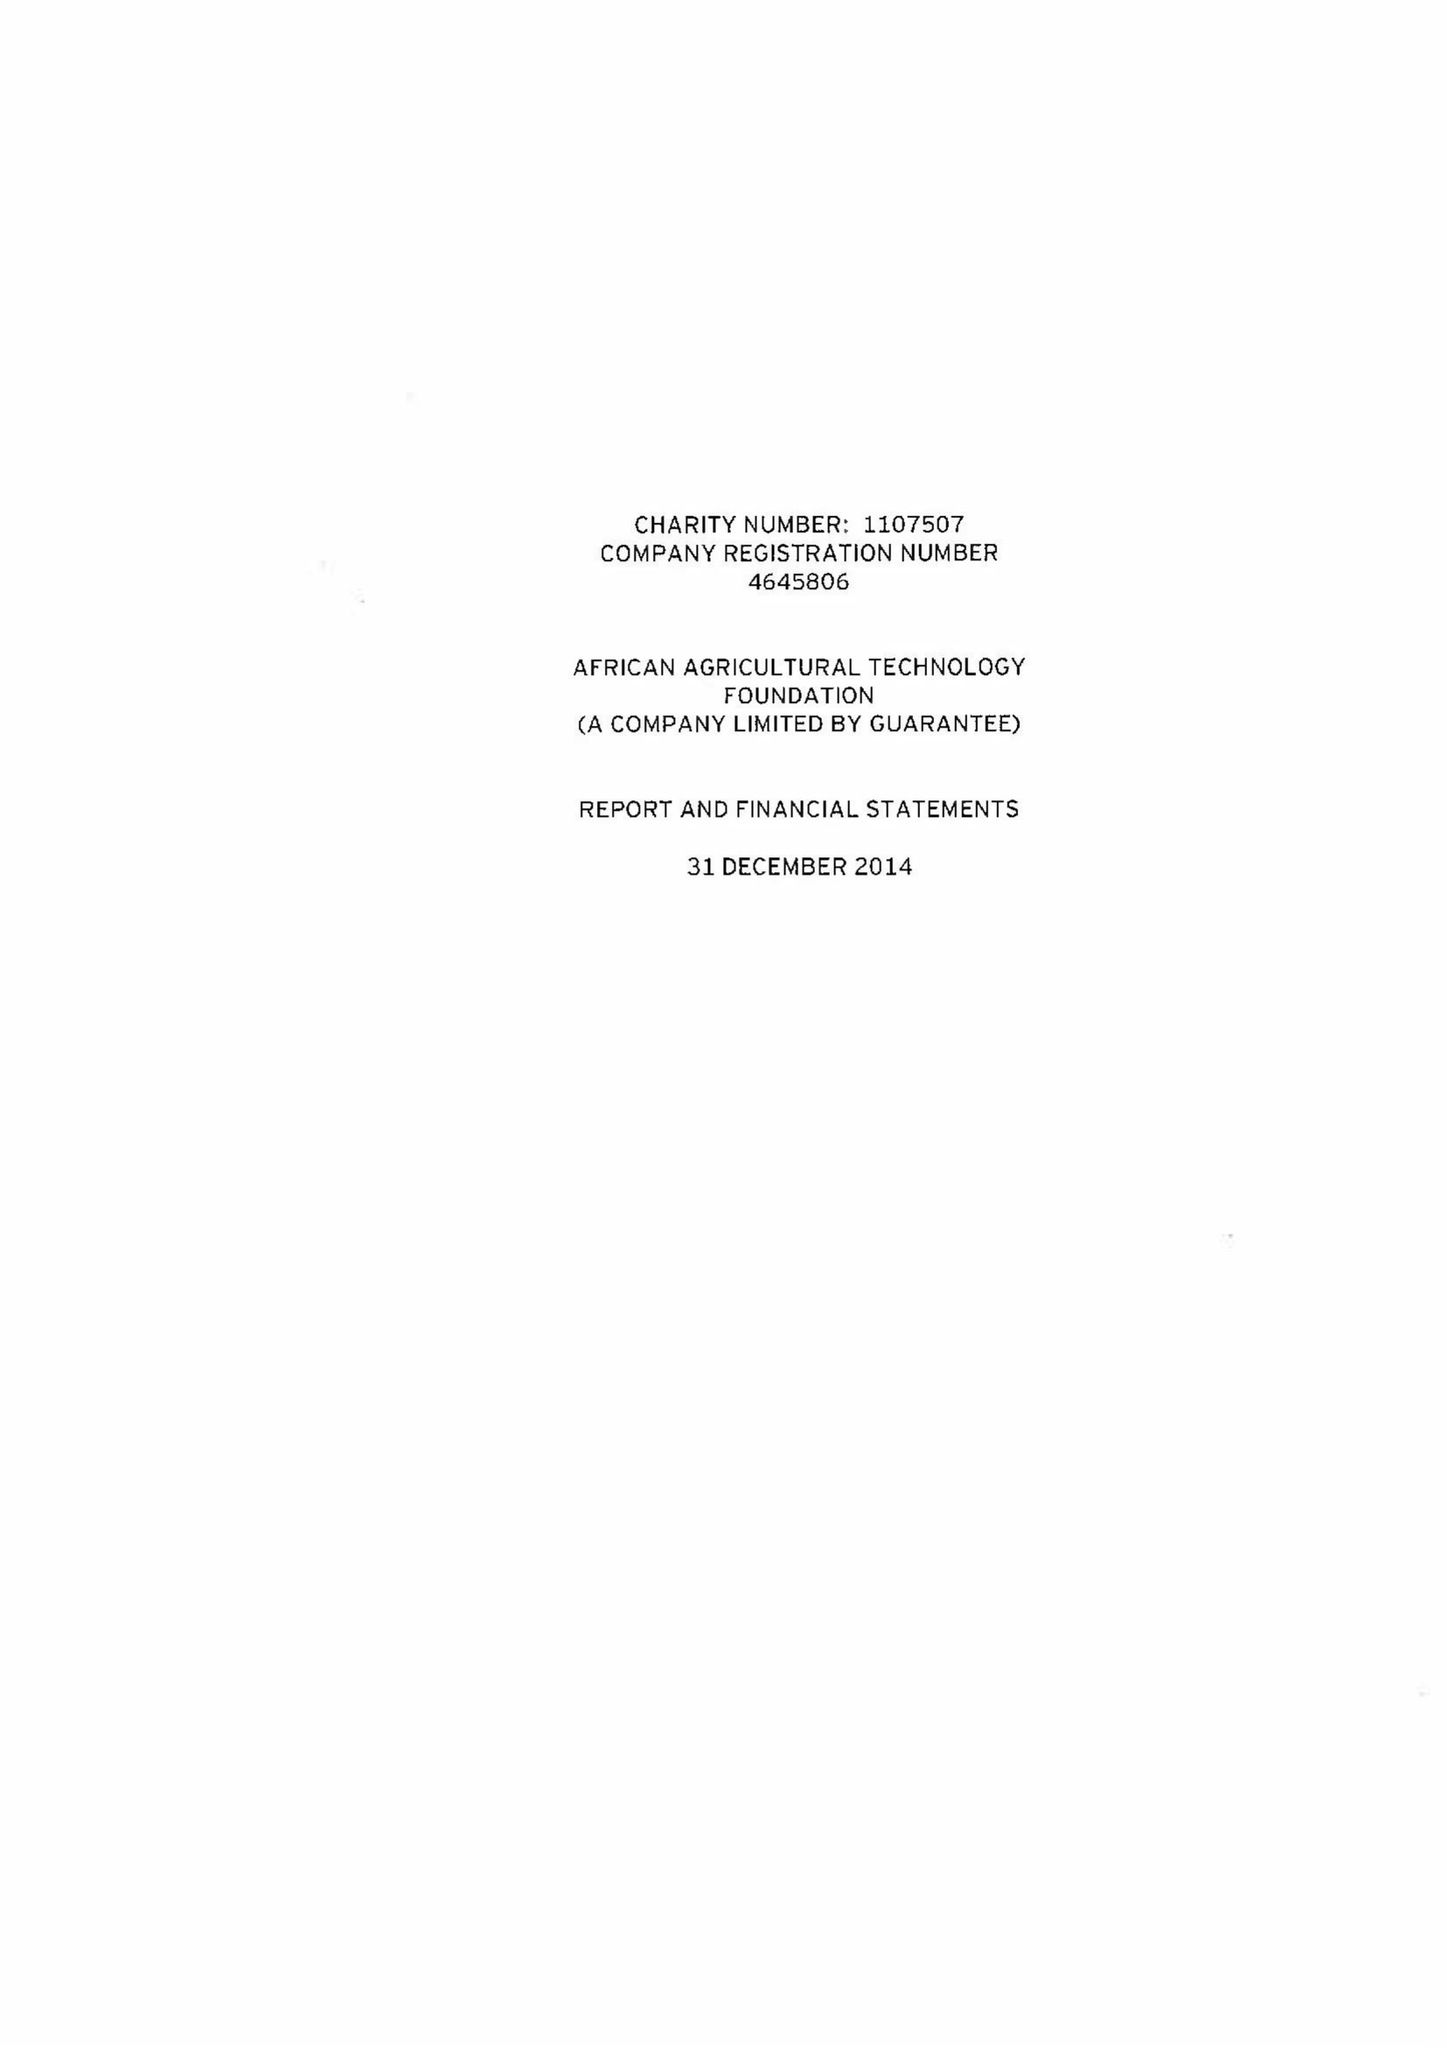What is the value for the income_annually_in_british_pounds?
Answer the question using a single word or phrase. 16654528.00 